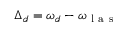Convert formula to latex. <formula><loc_0><loc_0><loc_500><loc_500>\Delta _ { d } = \omega _ { d } - \omega _ { l a s }</formula> 